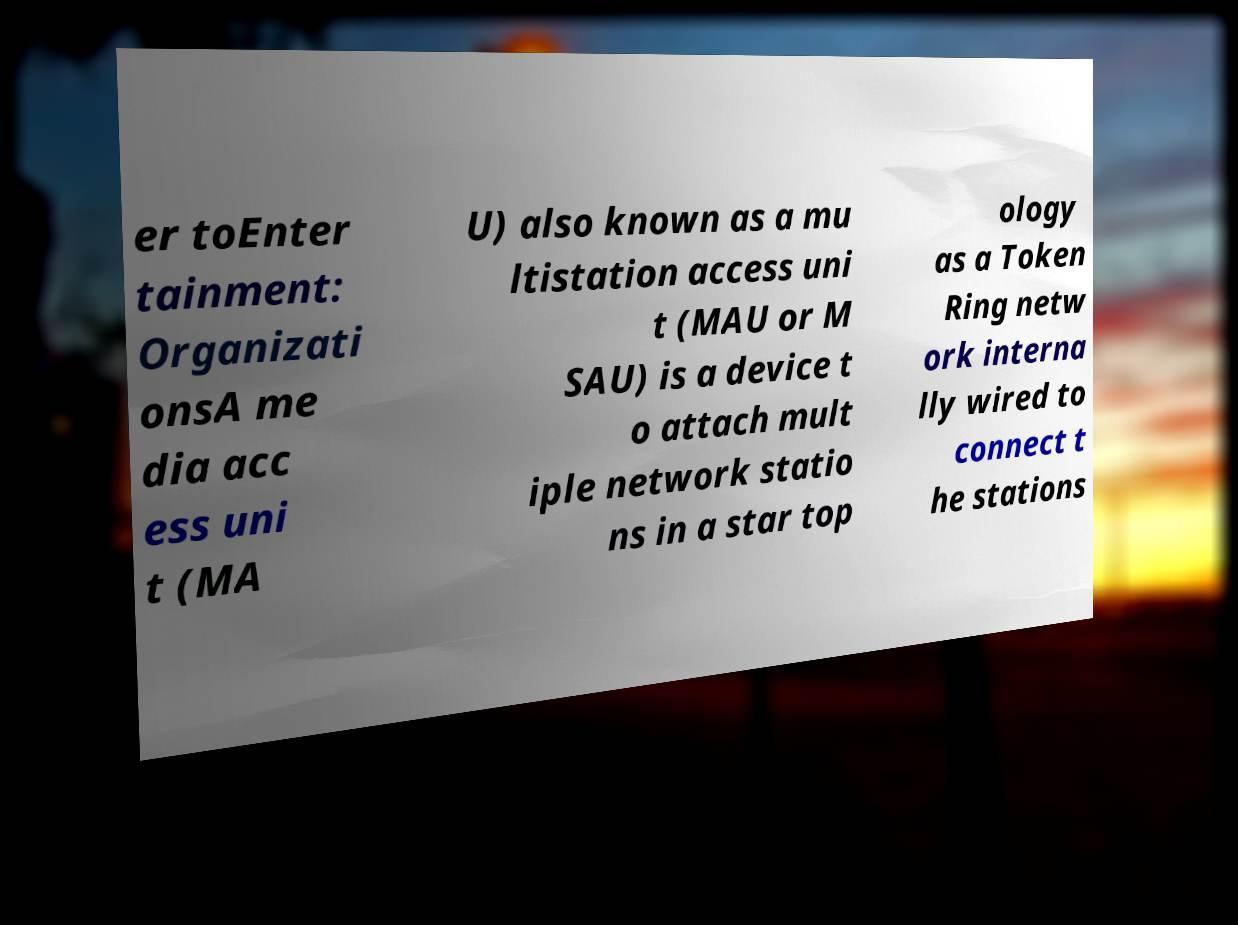Could you extract and type out the text from this image? er toEnter tainment: Organizati onsA me dia acc ess uni t (MA U) also known as a mu ltistation access uni t (MAU or M SAU) is a device t o attach mult iple network statio ns in a star top ology as a Token Ring netw ork interna lly wired to connect t he stations 